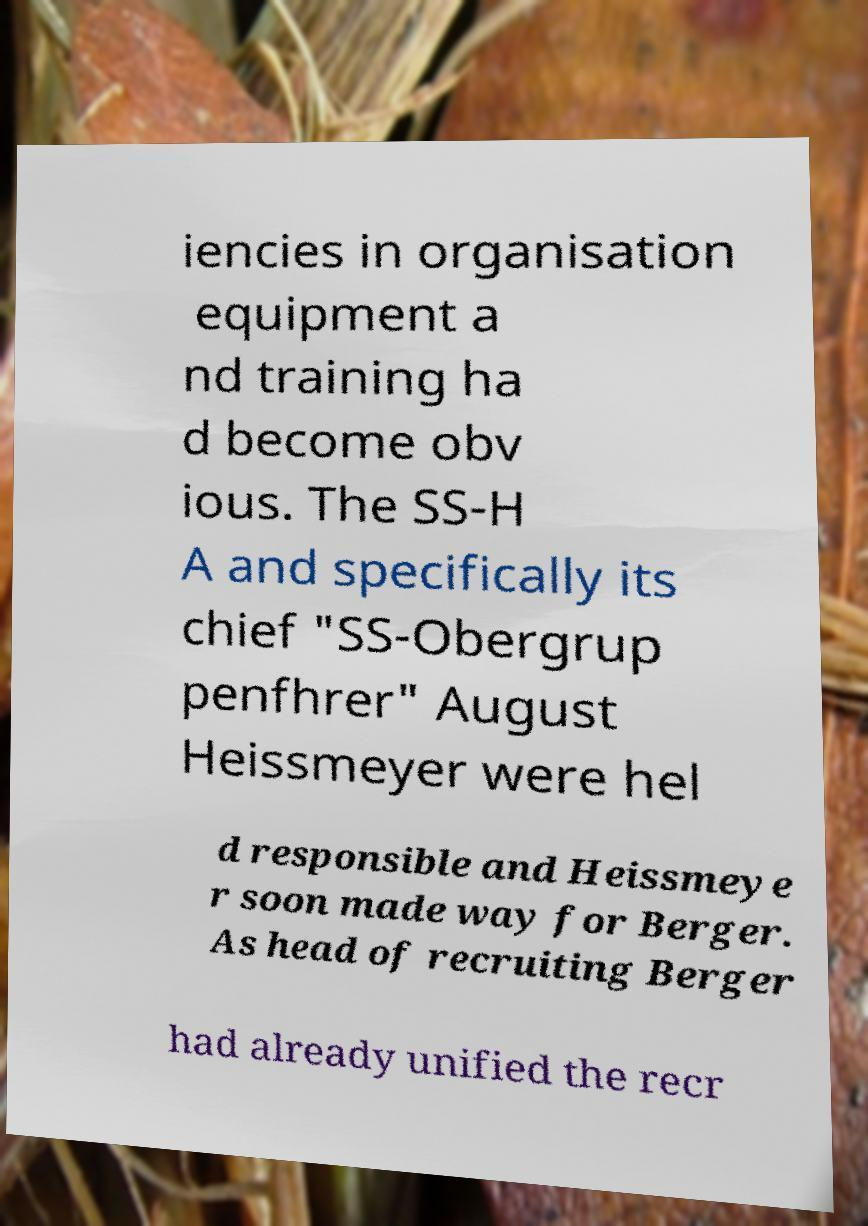Can you accurately transcribe the text from the provided image for me? iencies in organisation equipment a nd training ha d become obv ious. The SS-H A and specifically its chief "SS-Obergrup penfhrer" August Heissmeyer were hel d responsible and Heissmeye r soon made way for Berger. As head of recruiting Berger had already unified the recr 